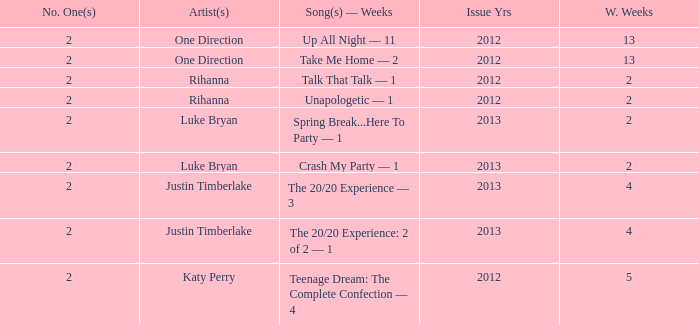What is the longest number of weeks any 1 song was at number #1? 13.0. 